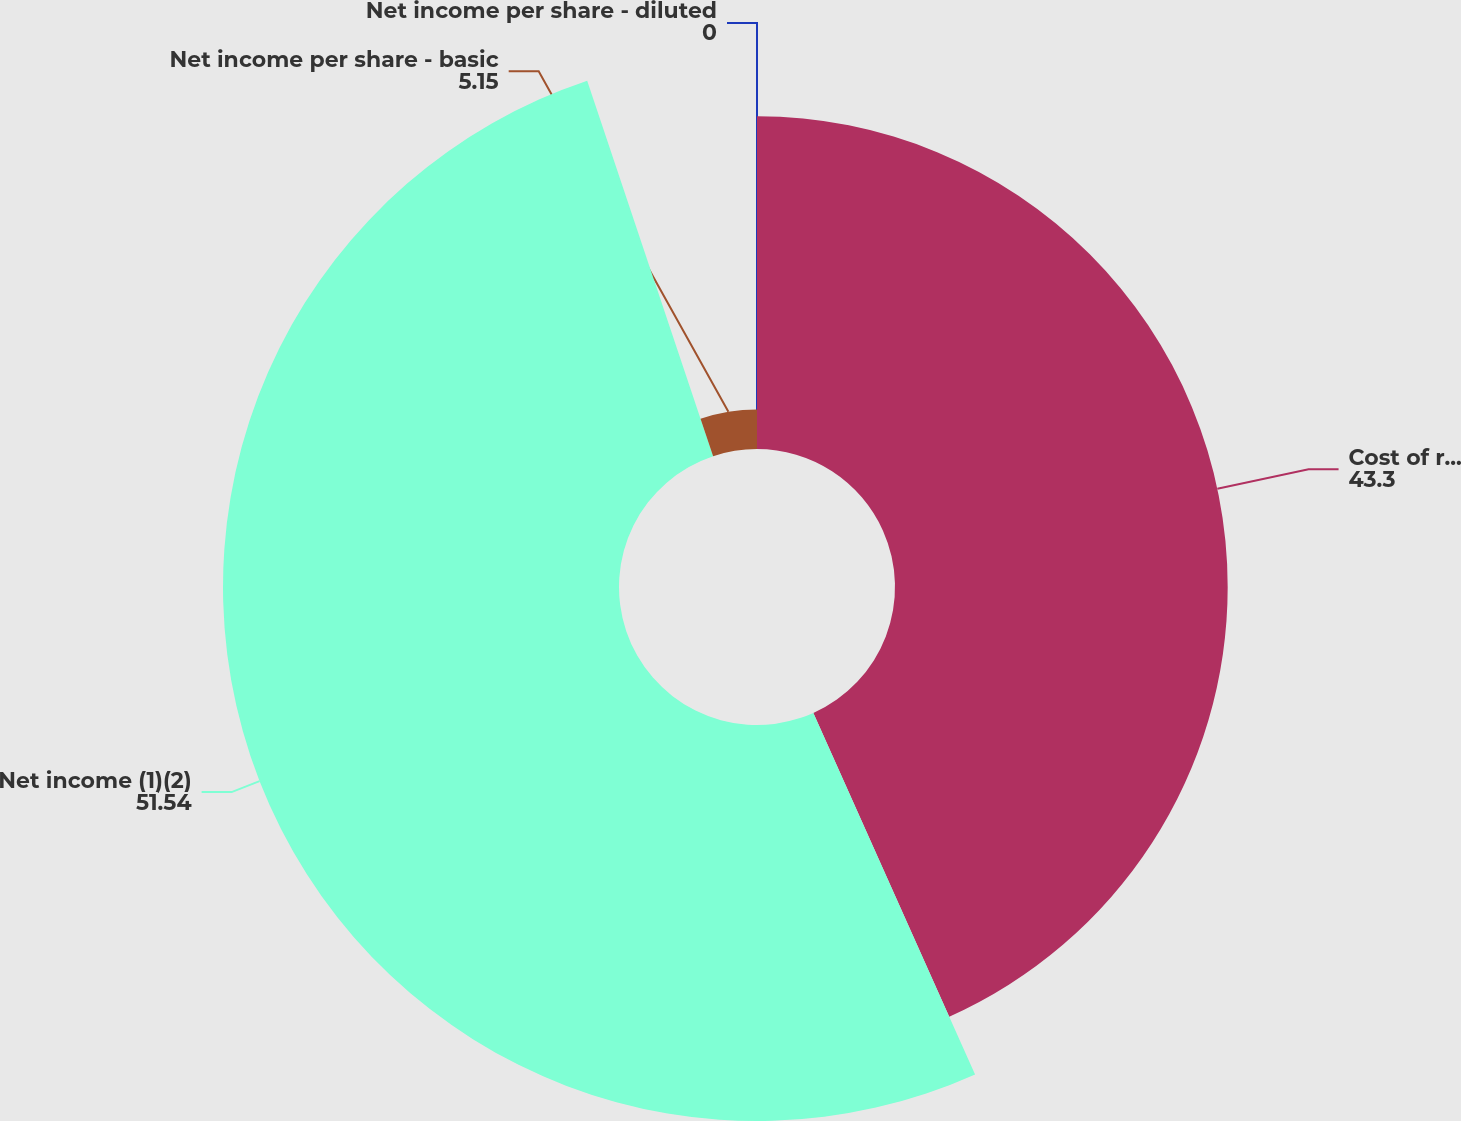Convert chart to OTSL. <chart><loc_0><loc_0><loc_500><loc_500><pie_chart><fcel>Cost of revenue<fcel>Net income (1)(2)<fcel>Net income per share - basic<fcel>Net income per share - diluted<nl><fcel>43.3%<fcel>51.54%<fcel>5.15%<fcel>0.0%<nl></chart> 